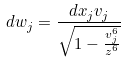Convert formula to latex. <formula><loc_0><loc_0><loc_500><loc_500>d w _ { j } = \frac { d x _ { j } v _ { j } } { \sqrt { 1 - \frac { v _ { j } ^ { 6 } } { z ^ { 6 } } } }</formula> 